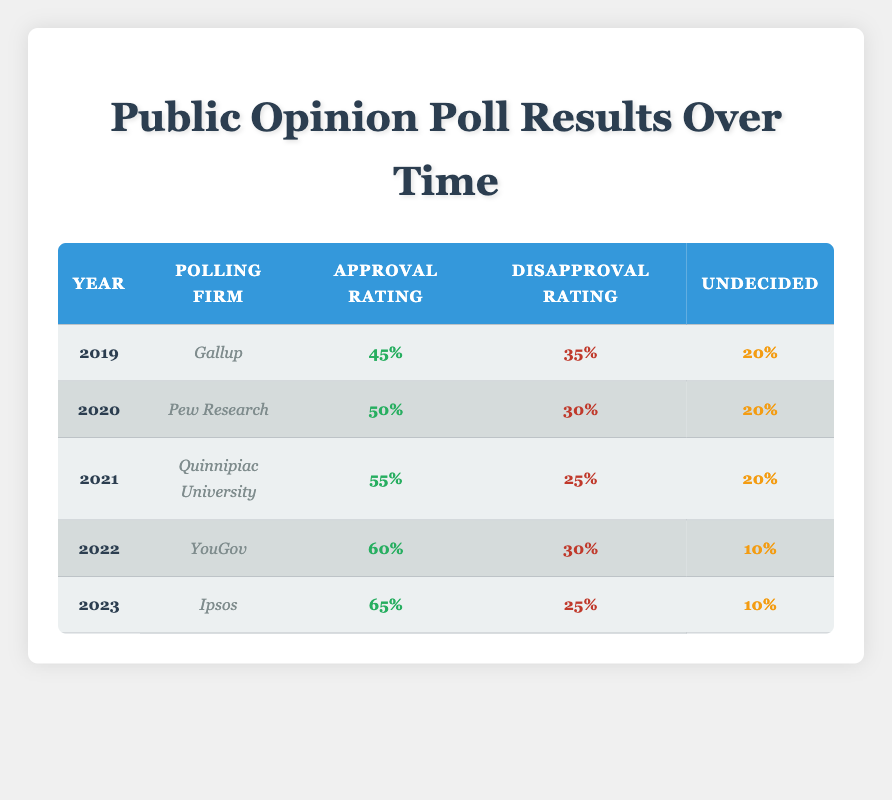What was the approval rating for John Smith in 2019? In the row corresponding to the year 2019, the approval rating listed is 45%.
Answer: 45% Which polling firm recorded the highest approval rating for John Smith, and what was that rating? The highest approval rating for John Smith was recorded by Ipsos in 2023, with a rating of 65%.
Answer: Ipsos, 65% What is the difference between the disapproval ratings in 2020 and 2023? The disapproval rating in 2020 was 30%, while in 2023 it was 25%. The difference is calculated as 30% - 25% = 5%.
Answer: 5% Did the approval rating for John Smith increase every year from 2019 to 2023? Yes, the approval rating increased each year: 45% in 2019, 50% in 2020, 55% in 2021, 60% in 2022, and 65% in 2023.
Answer: Yes What is the average disapproval rating for John Smith over these five years? The disapproval ratings for the years are 35%, 30%, 25%, 30%, and 25%. To find the average, sum these values (35 + 30 + 25 + 30 + 25 = 145) and divide by the number of years (5), resulting in an average disapproval rating of 29%.
Answer: 29% 